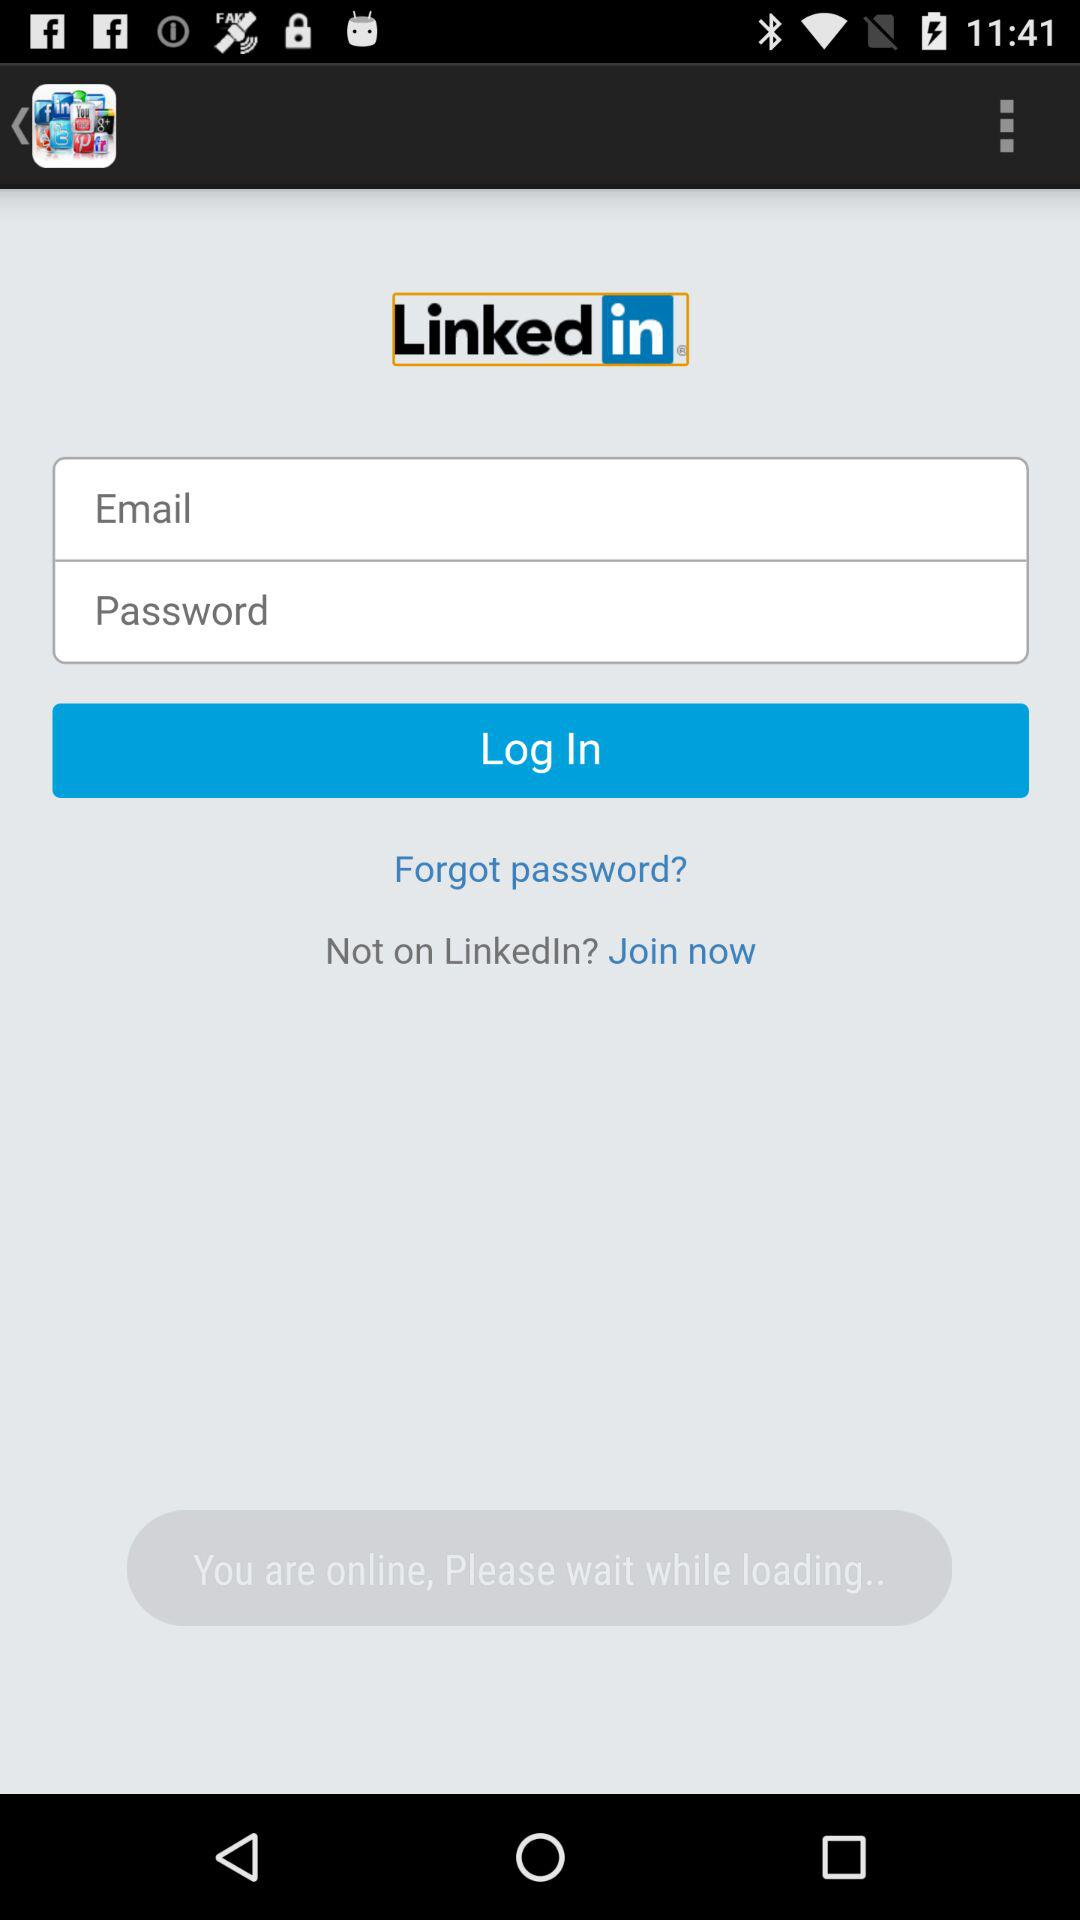What is the name of the application? The name of the application is "Linkedin". 